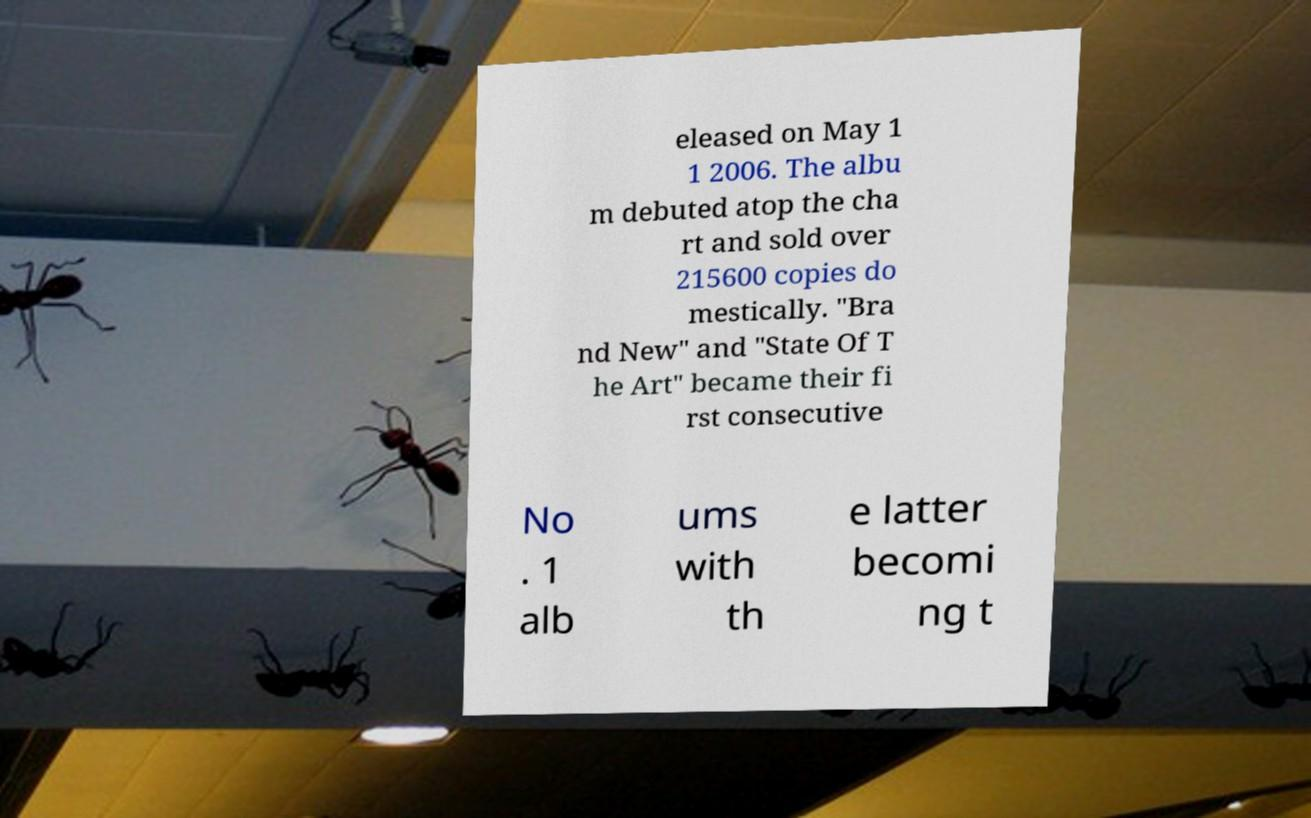Could you extract and type out the text from this image? eleased on May 1 1 2006. The albu m debuted atop the cha rt and sold over 215600 copies do mestically. "Bra nd New" and "State Of T he Art" became their fi rst consecutive No . 1 alb ums with th e latter becomi ng t 